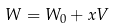<formula> <loc_0><loc_0><loc_500><loc_500>W = W _ { 0 } + x V</formula> 